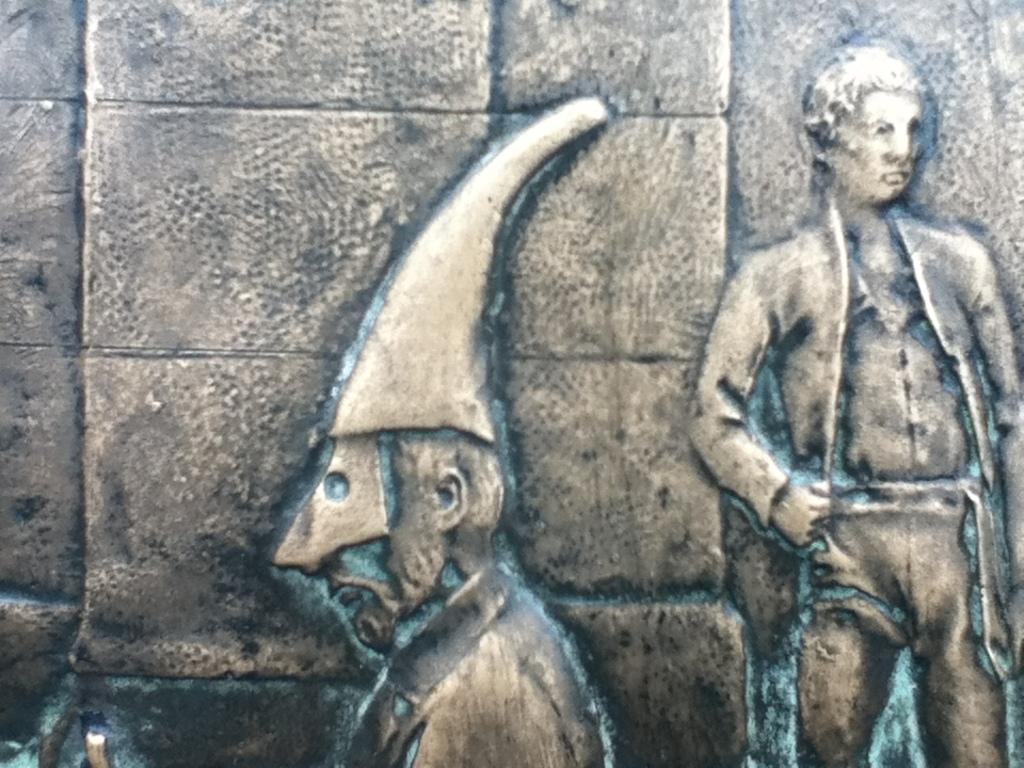What is on the wall in the image? There is a sculpture on the wall in the image. What does the sculpture depict? The sculpture depicts a person standing. What is the person in the sculpture wearing? The person in the sculpture is wearing clothes and a hat. What is the background of the image? There is a wall in the image. How many beds are visible in the image? There are no beds present in the image; it features a sculpture on a wall. What type of monkey can be seen interacting with the person in the sculpture? There is no monkey present in the image; the sculpture depicts a person standing alone. 